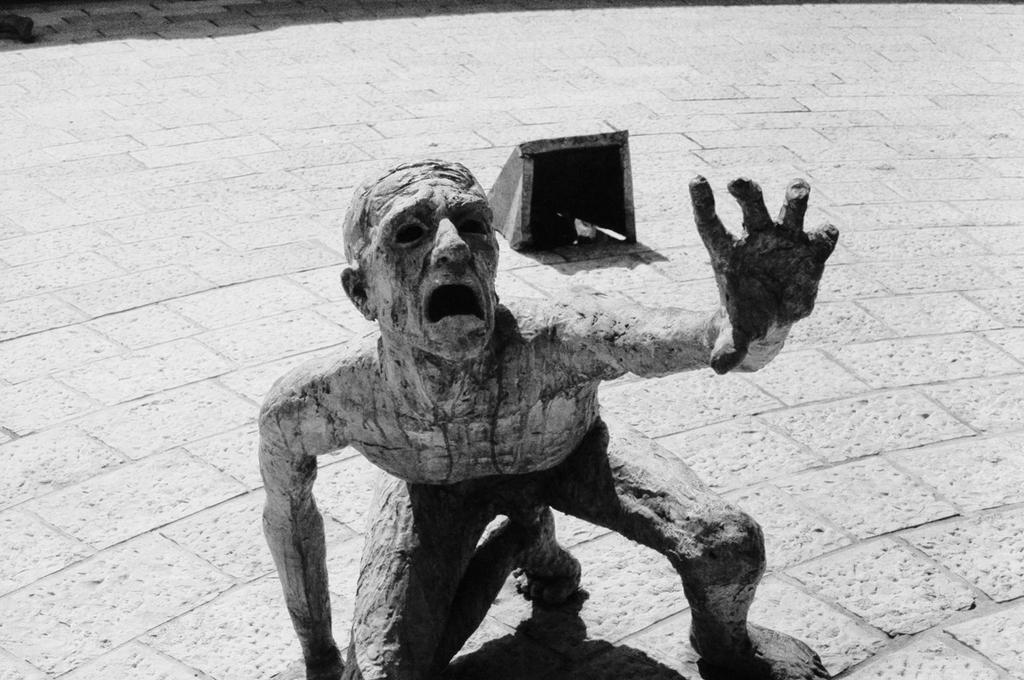In one or two sentences, can you explain what this image depicts? In this picture, we see a statue of a man on the ground and we see a light with a cover on it on the floor. 